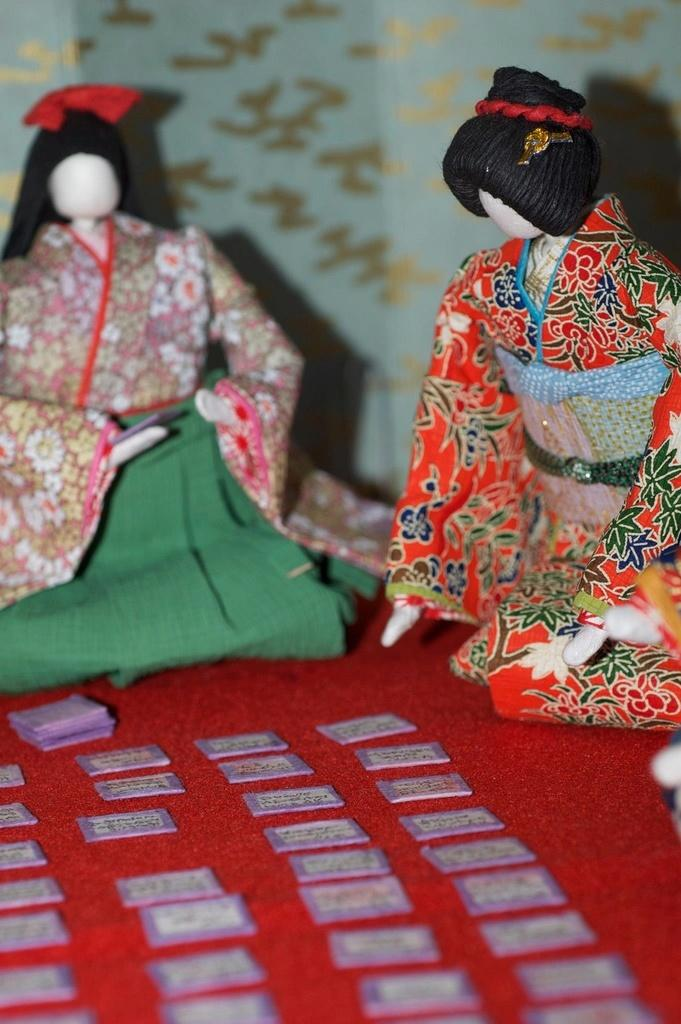What type of crafts are featured in the image? There are Japanese paper crafts in the image. What other items can be seen in the image? There are cards in the image. What is the color of the carpet on which the cards are placed? The carpet is red. What is the name of the shape that the cards form on the red carpet? The cards do not form a specific shape on the red carpet, so it is not possible to determine a name for the shape. 